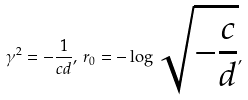<formula> <loc_0><loc_0><loc_500><loc_500>\gamma ^ { 2 } = { - \frac { 1 } { c d } } , \, r _ { 0 } = - \log \sqrt { - \frac { c } { d } } ,</formula> 